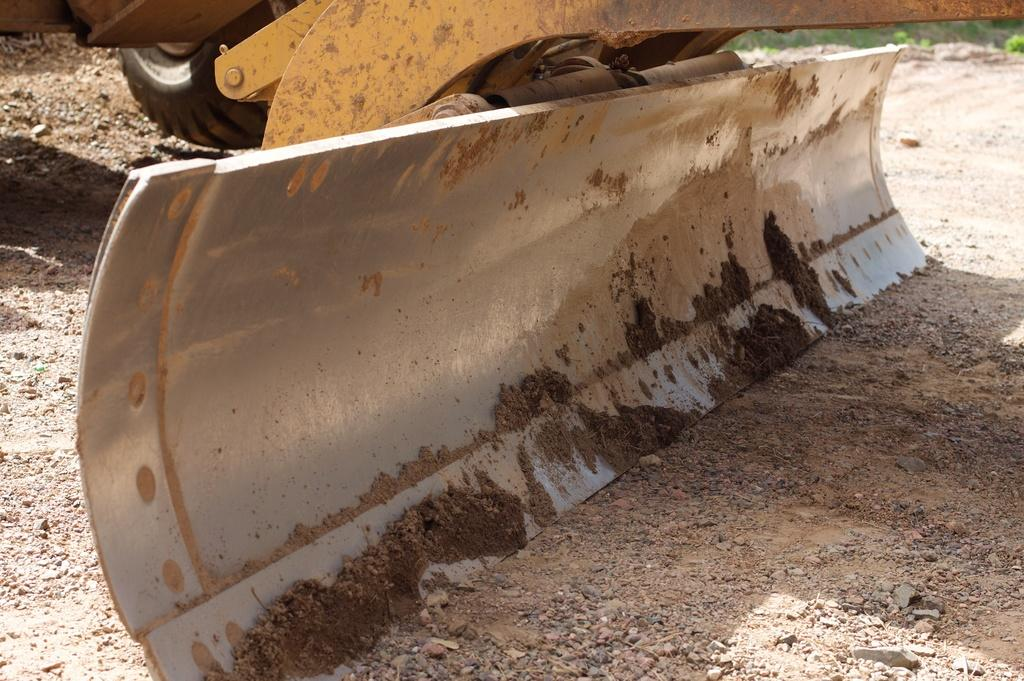What type of vehicle is in the image? There is a bulldozer in the image. What color is the bulldozer? The bulldozer is yellow. Where is the bulldozer located in the image? The bulldozer is on the ground. What type of vegetation can be seen in the image? There is grass visible in the image. What type of debt is associated with the bulldozer in the image? There is no mention of debt in the image, and therefore no such association can be made. 